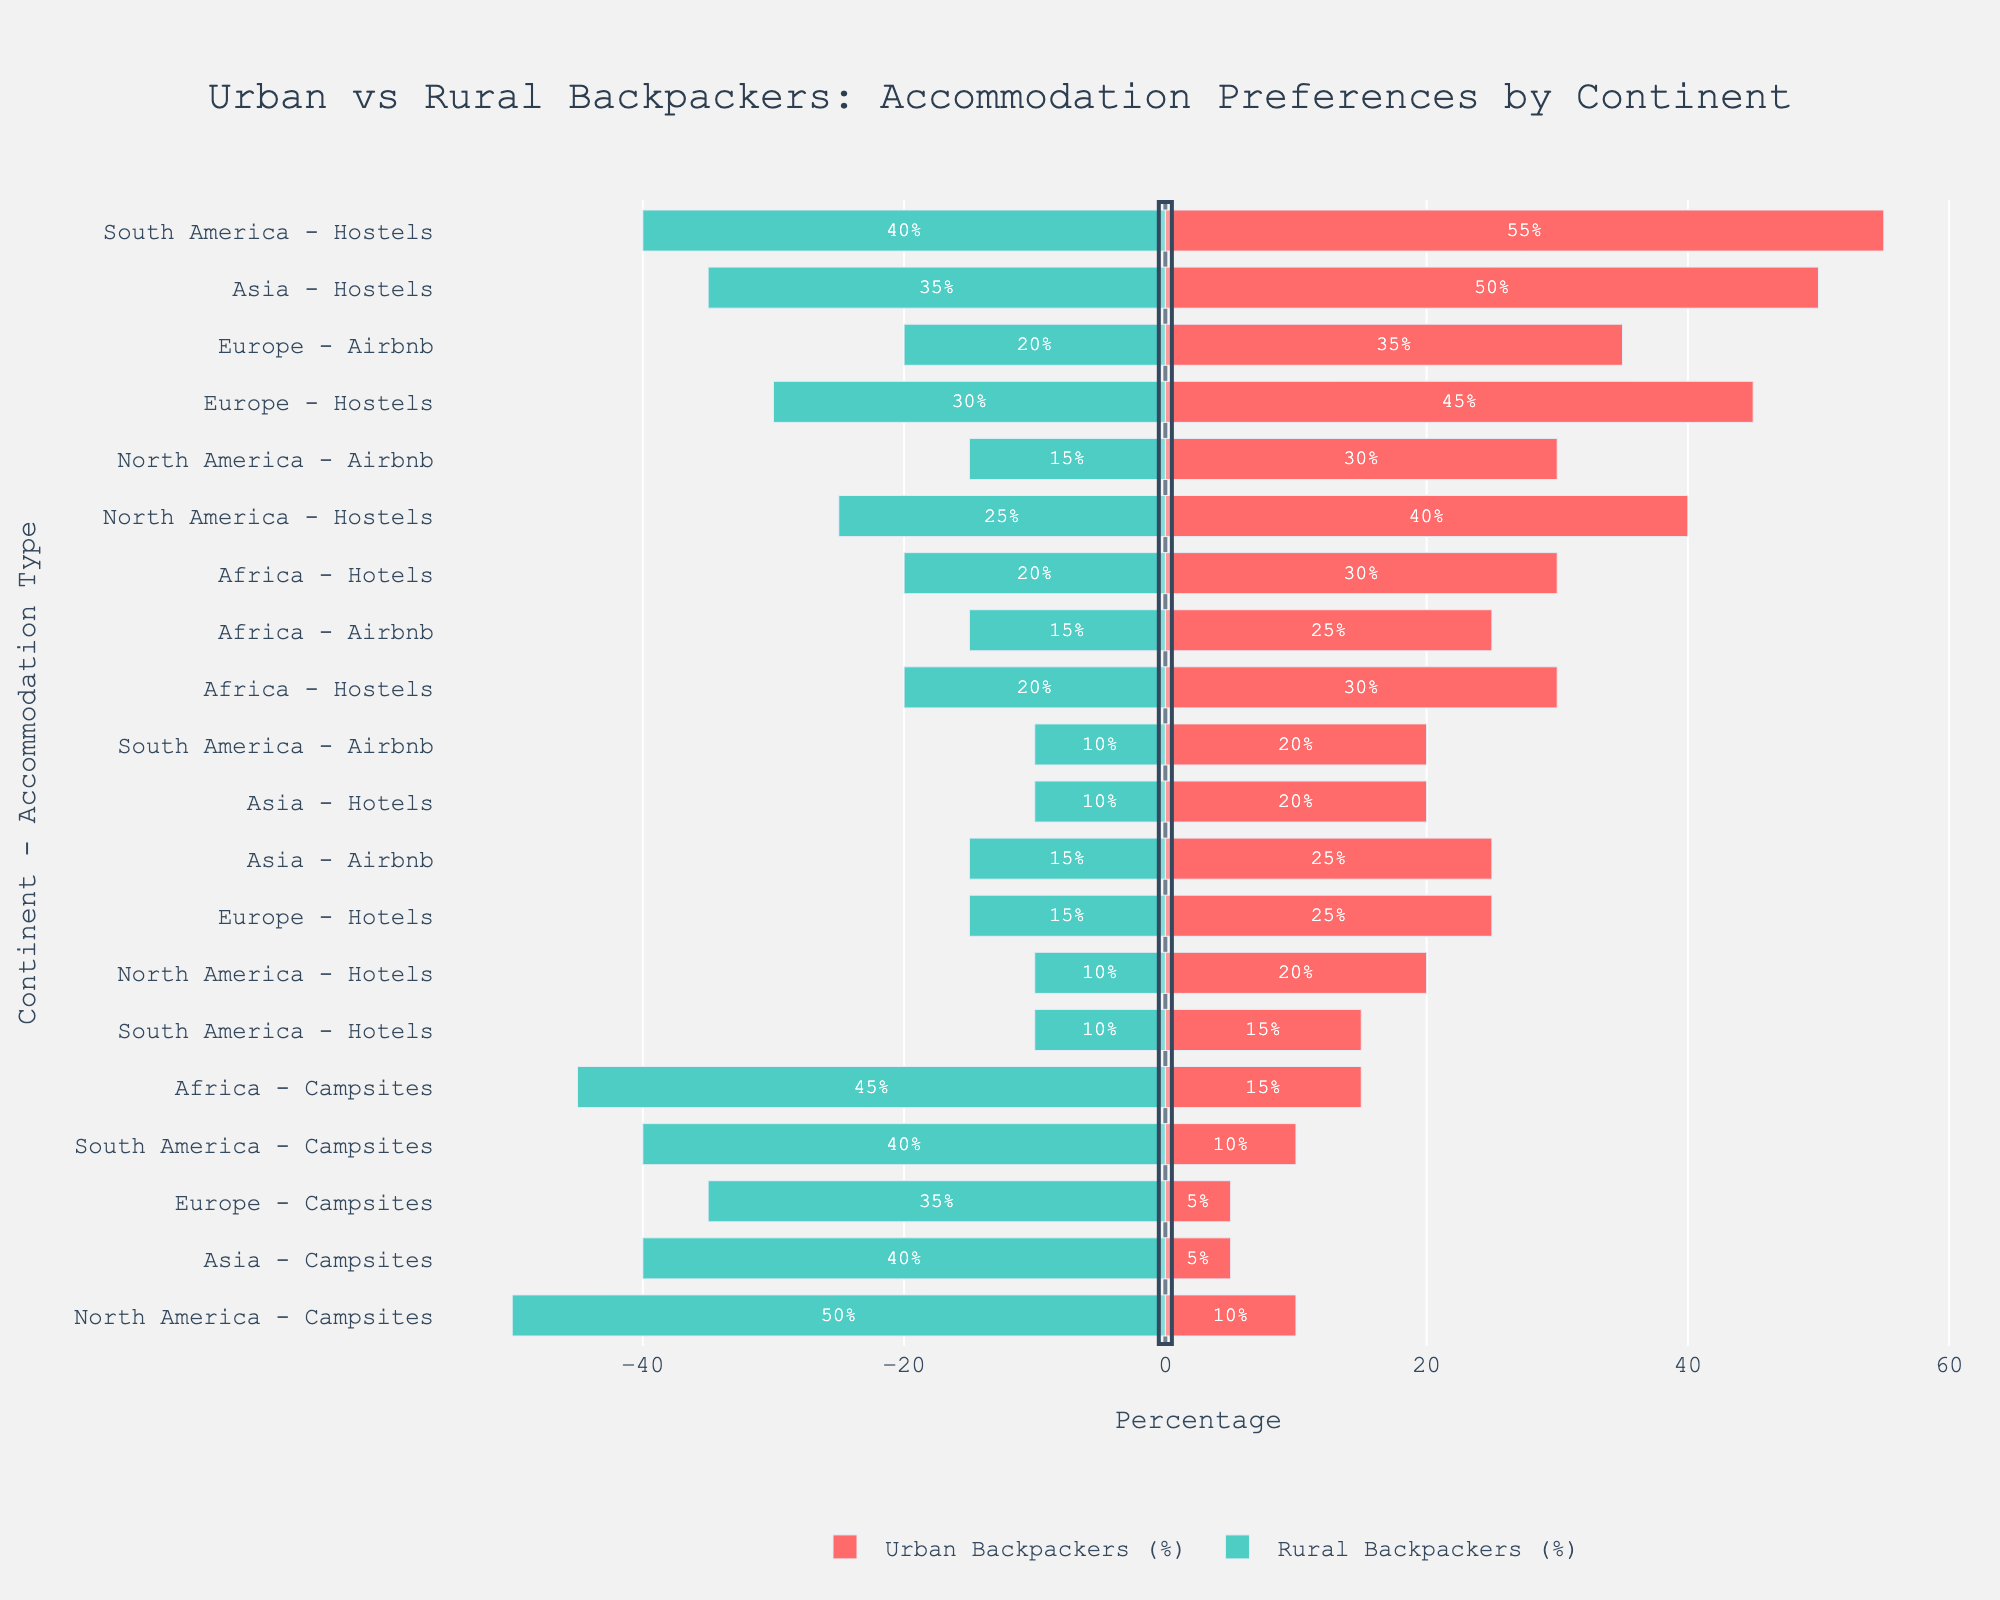Which continent has the highest percentage of urban backpackers preferring hostels? The bar lengths representing urban backpackers' preferences for hostels are tallest for each continent. Compare all continents and identify that South America has the tallest bar for urban backpackers preferring hostels at 55%.
Answer: South America Which continent has the highest percentage difference between urban and rural backpackers in campsites? Calculate the absolute difference in percentages between urban and rural backpackers for campsites across all continents. North America has the highest difference:
Answer: 40% (50% - 10%) Which accommodation type is most preferred by rural backpackers in Europe? Examine the negative side of the bars (representing rural backpackers) for Europe and compare their lengths. Campsites have the longest bar at 35%.
Answer: Campsites What is the combined percentage for urban backpackers preferring Airbnb and hotels in North America? Add the percentages of urban backpackers for Airbnb and hotels in North America: 30% + 20% = 50%.
Answer: 50% Which continent has the least preference for campsites among urban backpackers? Compare the lengths of bars representing urban backpackers' preferences for campsites across all continents. Europe and Asia both have the lowest at 5%.
Answer: Europe and Asia Which accommodation type has the smallest disparity in preference between urban and rural backpackers in Africa? Calculate the absolute differences in percentages between urban and rural backpackers for each accommodation type in Africa. Airbnb has the smallest difference: 10% (25% - 15%).
Answer: Airbnb How does the preference for hotels between urban and rural backpackers in Asia compare? Compare positive and negative bars for hotels in Asia. Both urban and rural backpackers have the same percentage (20% and 10% respectively).
Answer: Urban backpackers prefer hotels more in Asia Which continent has a higher rural preference for hostels compared to urban preference? Compare positive and negative bars for hostels across each continent. No such continent exists. All urban preferences outweigh rural ones.
Answer: None What is the average preference percentage of urban backpackers for Airbnb across all continents? Sum the percentages of urban backpackers preferring Airbnb across all continents (30 + 35 + 25 + 20 + 25 = 135), then divide by 5 (number of continents): 135 / 5 = 27%.
Answer: 27% In which continent do urban backpackers prefer hotels equally as much as rural backpackers prefer hostels? Compare positive bars for hotels and corresponding negative bars for hostels across each continent. Africa shows a 30% preference for both categories.
Answer: Africa 